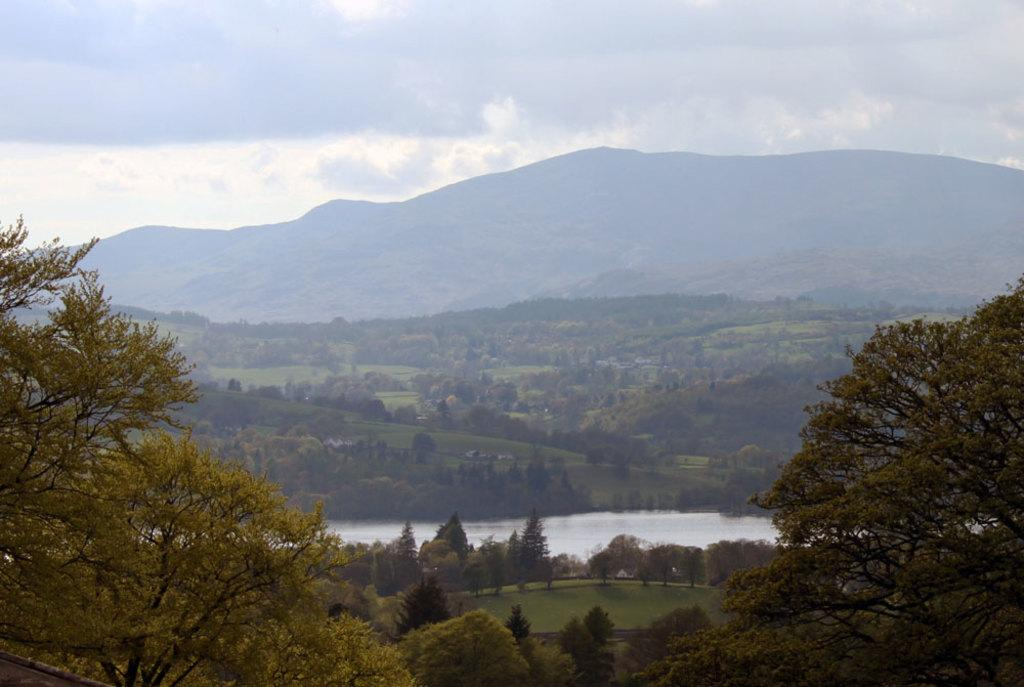What is the main feature in the center of the image? There is a canal in the center of the image. What type of vegetation can be seen at the bottom of the image? There are trees at the bottom of the image. What can be seen in the distance in the image? There are hills visible in the background of the image. What is visible above the hills in the image? The sky is visible in the background of the image. Where is the toothbrush located in the image? There is no toothbrush present in the image. What type of horses can be seen running alongside the canal in the image? There are no horses present in the image; it features a canal, trees, hills, and the sky. 